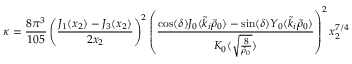<formula> <loc_0><loc_0><loc_500><loc_500>\kappa = \frac { 8 \pi ^ { 3 } } { 1 0 5 } \left ( \frac { J _ { 1 } ( x _ { 2 } ) - J _ { 3 } ( x _ { 2 } ) } { 2 x _ { 2 } } \right ) ^ { 2 } \left ( \frac { \cos ( \delta ) J _ { 0 } ( \tilde { k } _ { i } \tilde { \rho } _ { 0 } ) - \sin ( \delta ) Y _ { 0 } ( \tilde { k } _ { i } \tilde { \rho } _ { 0 } ) } { K _ { 0 } ( \sqrt { \frac { 8 } { \tilde { \rho } _ { 0 } } } ) } \right ) ^ { 2 } x _ { 2 } ^ { 7 / 4 }</formula> 